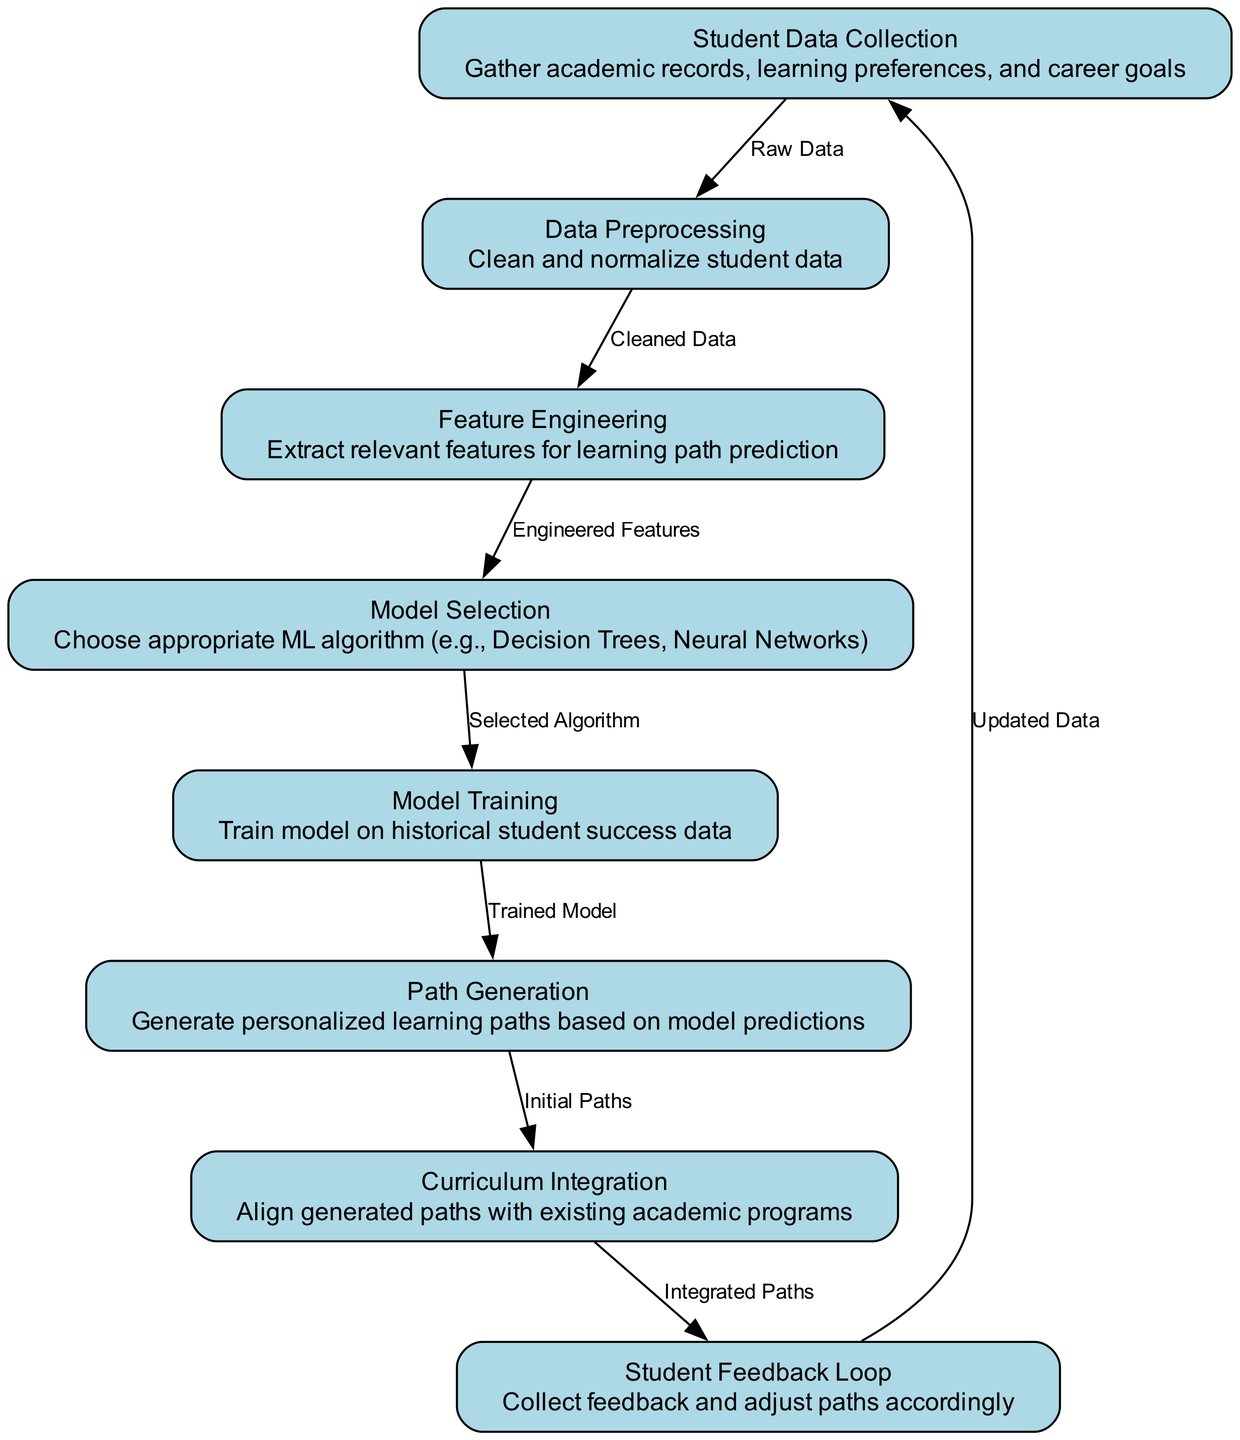What is the first node in the diagram? The first node in the diagram is "Student Data Collection," as it is the starting point of the machine learning pipeline, with the ID "1".
Answer: Student Data Collection How many nodes are present in the pipeline? The diagram includes a total of eight nodes, each representing a different step in the machine learning pipeline.
Answer: 8 Which node follows "Data Preprocessing"? The node that follows "Data Preprocessing" is "Feature Engineering," as indicated by the directed edge from "2" to "3" in the diagram.
Answer: Feature Engineering What type of algorithm is chosen during the "Model Selection" phase? During the "Model Selection" phase, appropriate machine learning algorithms are chosen, such as Decision Trees or Neural Networks, as specified in the description of node "4".
Answer: Decision Trees, Neural Networks Describe the output after "Path Generation". After "Path Generation," the output is the "Initial Paths," which are generated based on the model predictions, as shown by the edge connecting nodes "6" and "7".
Answer: Initial Paths What is the final node in the diagram? The final node in the diagram is "Student Feedback Loop," as it directly connects back to the first node "Student Data Collection," completing the feedback loop in the process.
Answer: Student Feedback Loop What relationship exists between "Curriculum Integration" and "Student Feedback Loop"? The relationship is that "Curriculum Integration" outputs "Integrated Paths," which then feed into the "Student Feedback Loop" to iterate on the learning paths based on feedback, as shown by the edge from node "7" to node "8".
Answer: Integrated Paths Which edge connects "Model Training" to "Path Generation"? The edge that connects "Model Training" to "Path Generation" carries the label "Trained Model," indicating that the generated paths are based on the trained model from node "5".
Answer: Trained Model 